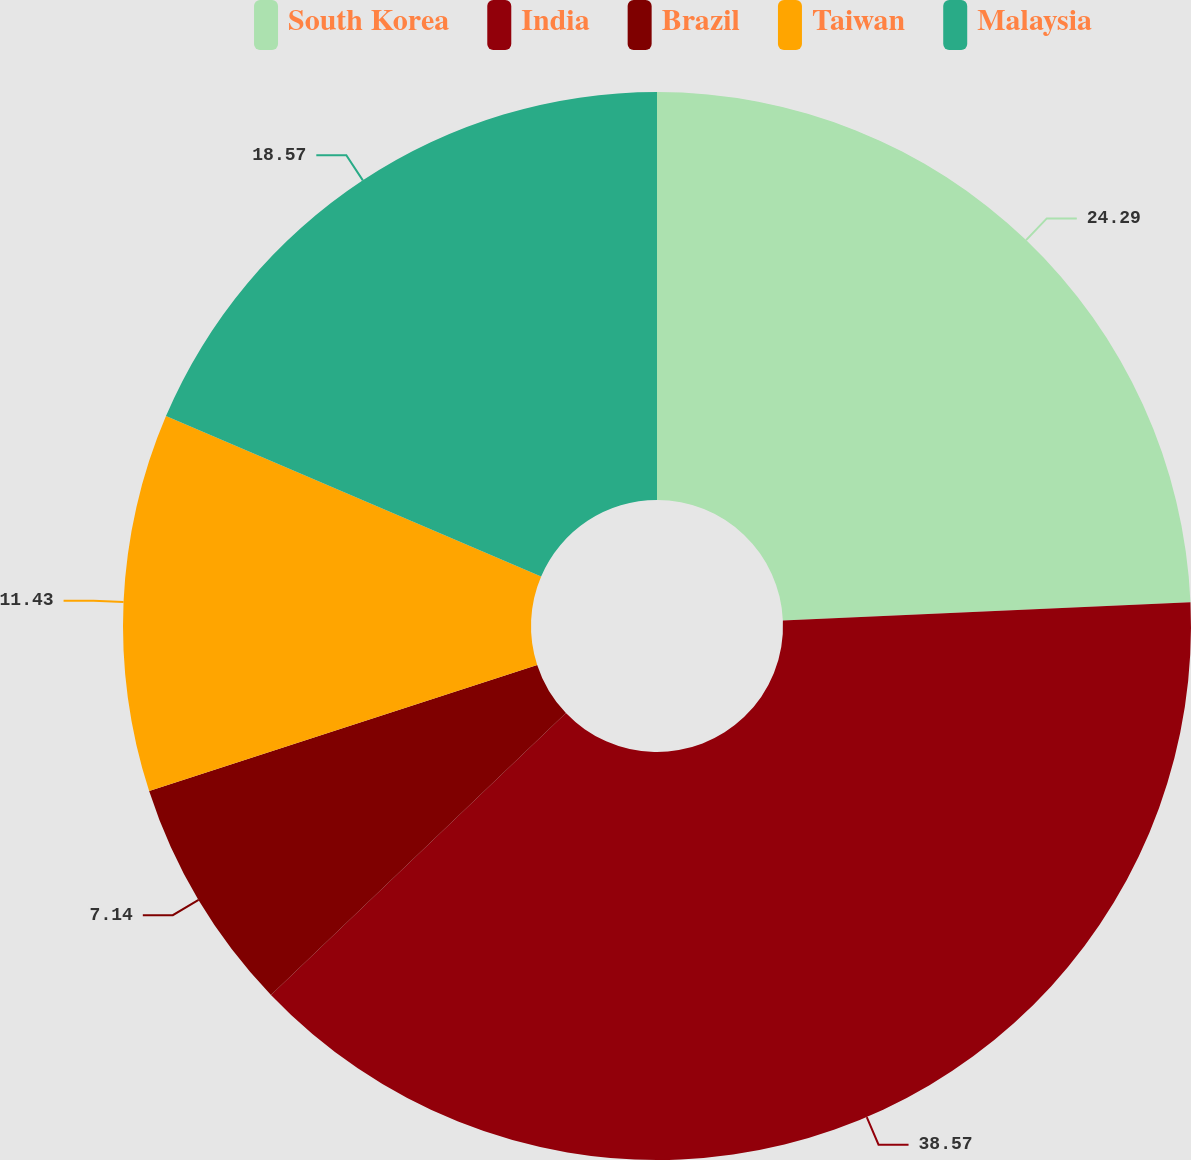Convert chart to OTSL. <chart><loc_0><loc_0><loc_500><loc_500><pie_chart><fcel>South Korea<fcel>India<fcel>Brazil<fcel>Taiwan<fcel>Malaysia<nl><fcel>24.29%<fcel>38.57%<fcel>7.14%<fcel>11.43%<fcel>18.57%<nl></chart> 